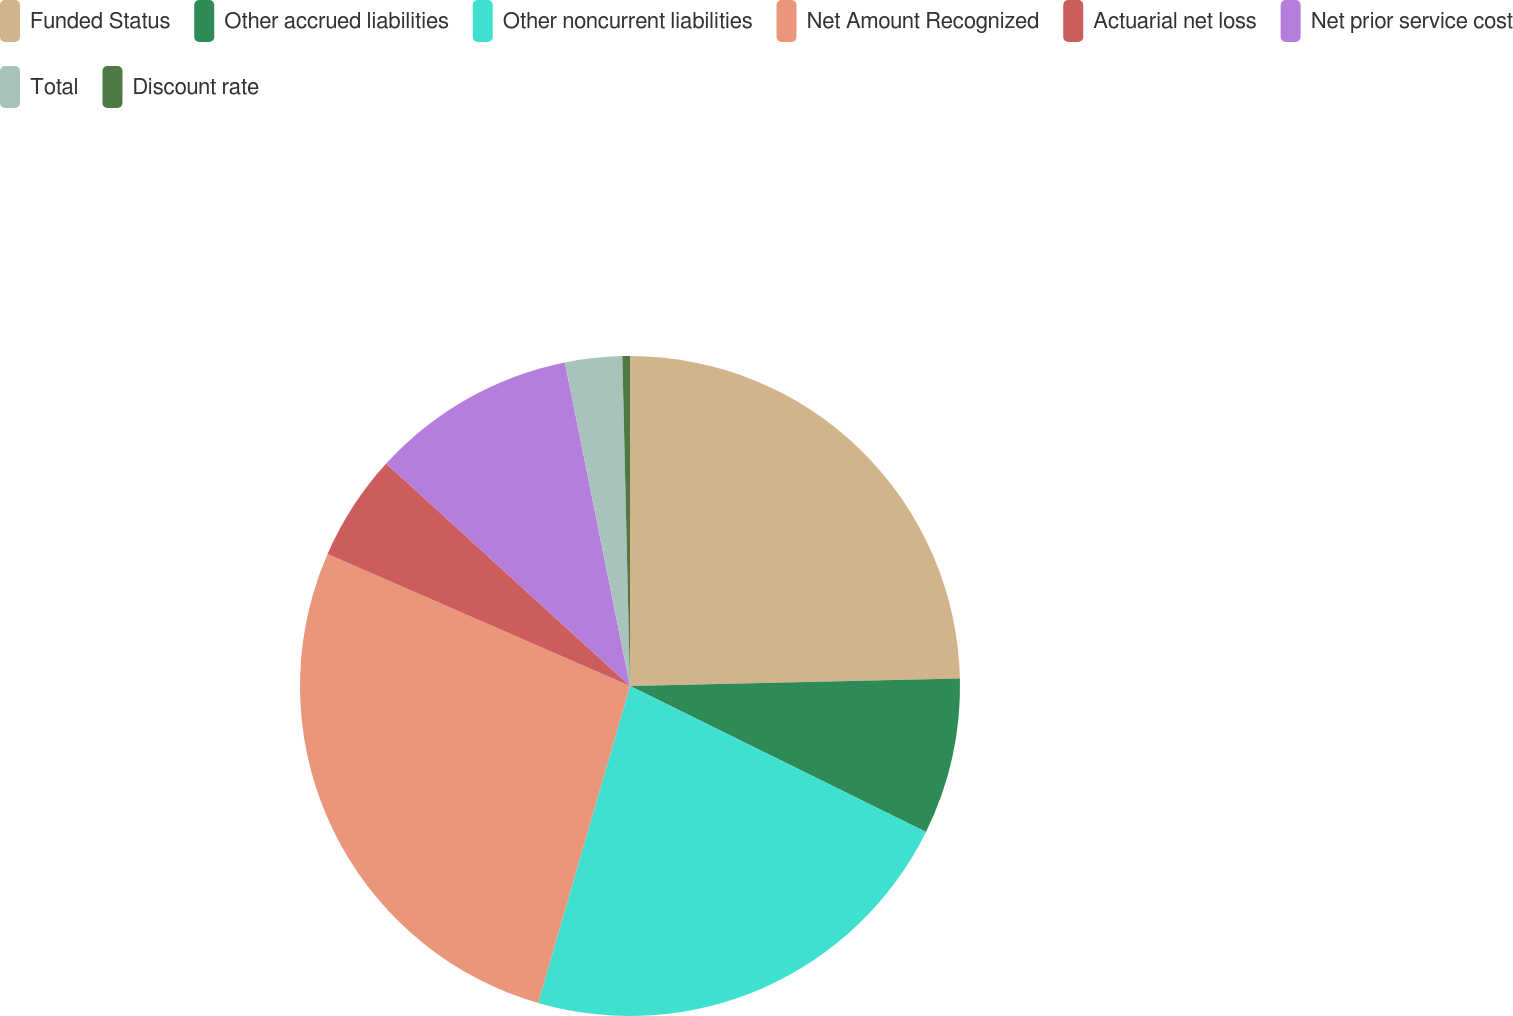<chart> <loc_0><loc_0><loc_500><loc_500><pie_chart><fcel>Funded Status<fcel>Other accrued liabilities<fcel>Other noncurrent liabilities<fcel>Net Amount Recognized<fcel>Actuarial net loss<fcel>Net prior service cost<fcel>Total<fcel>Discount rate<nl><fcel>24.64%<fcel>7.65%<fcel>22.2%<fcel>27.06%<fcel>5.22%<fcel>10.07%<fcel>2.79%<fcel>0.37%<nl></chart> 